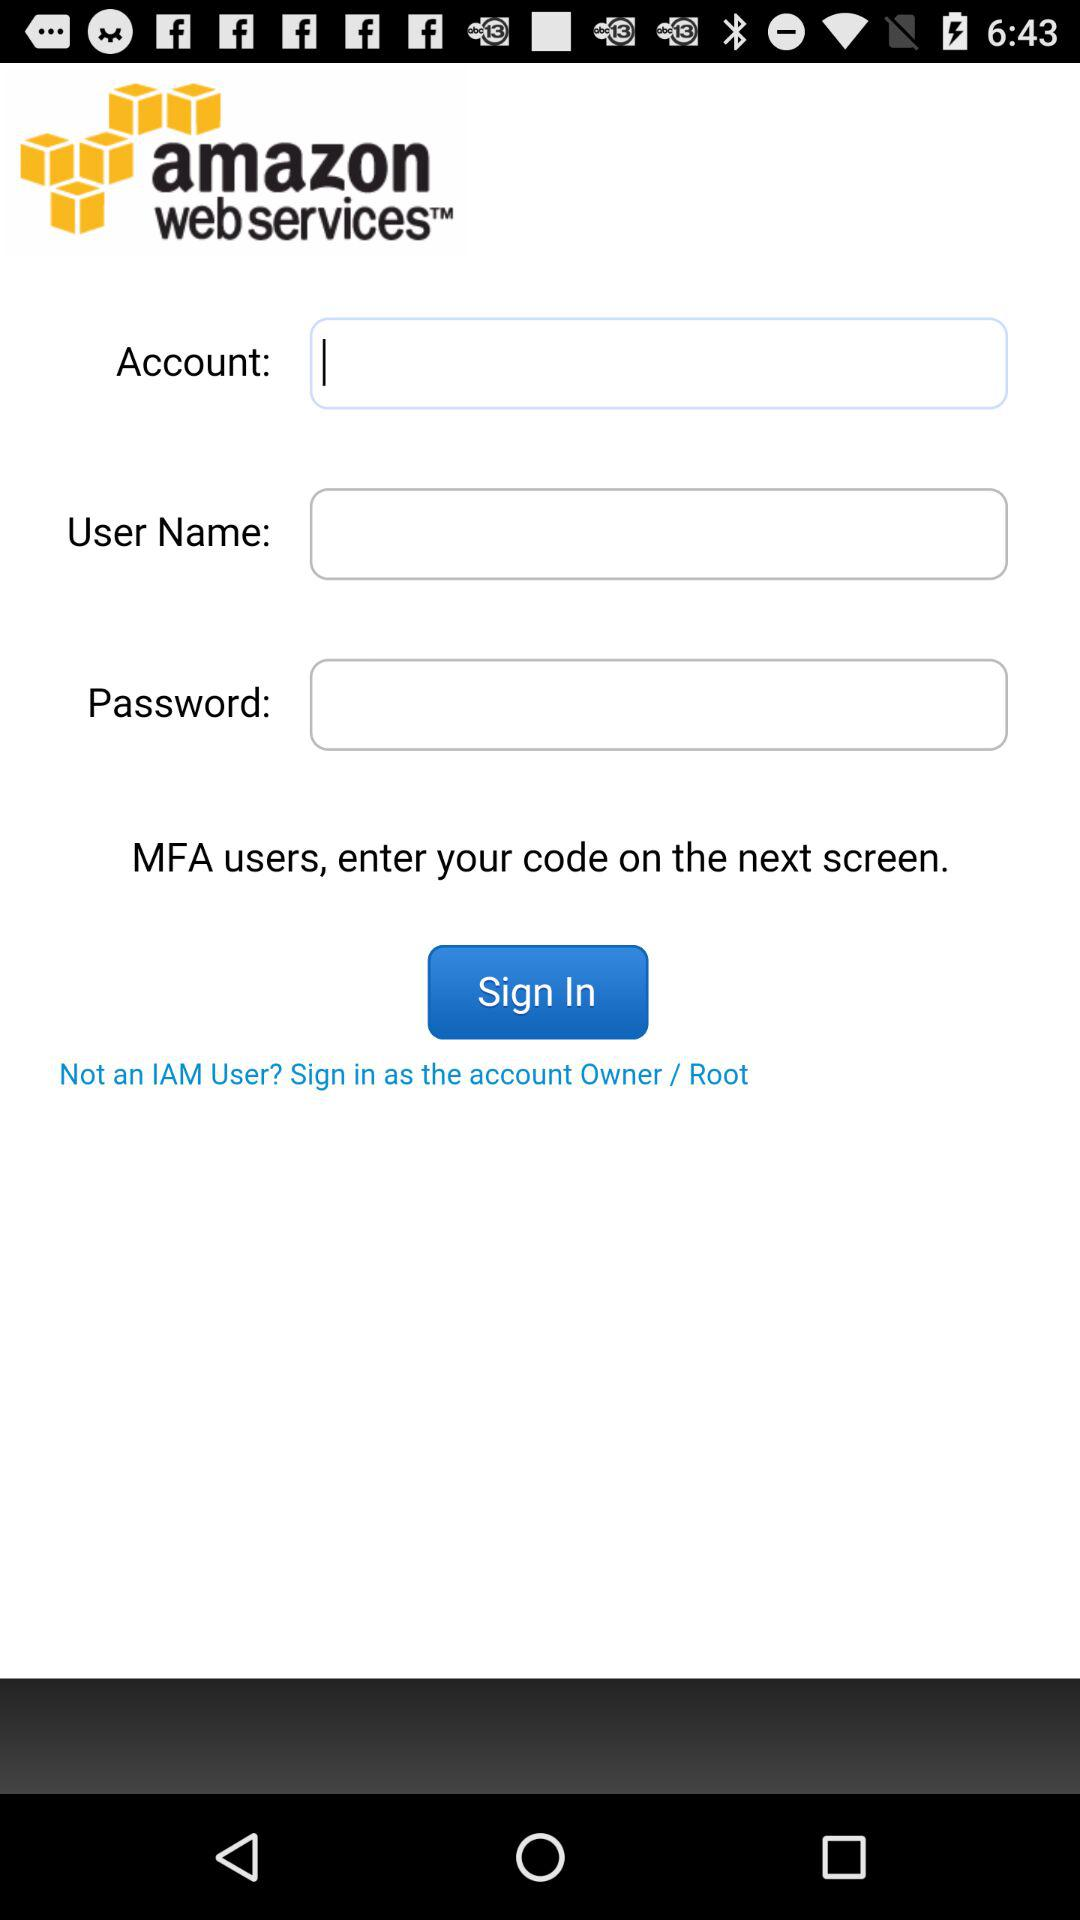What is the application name? The application name is "amazon web services". 